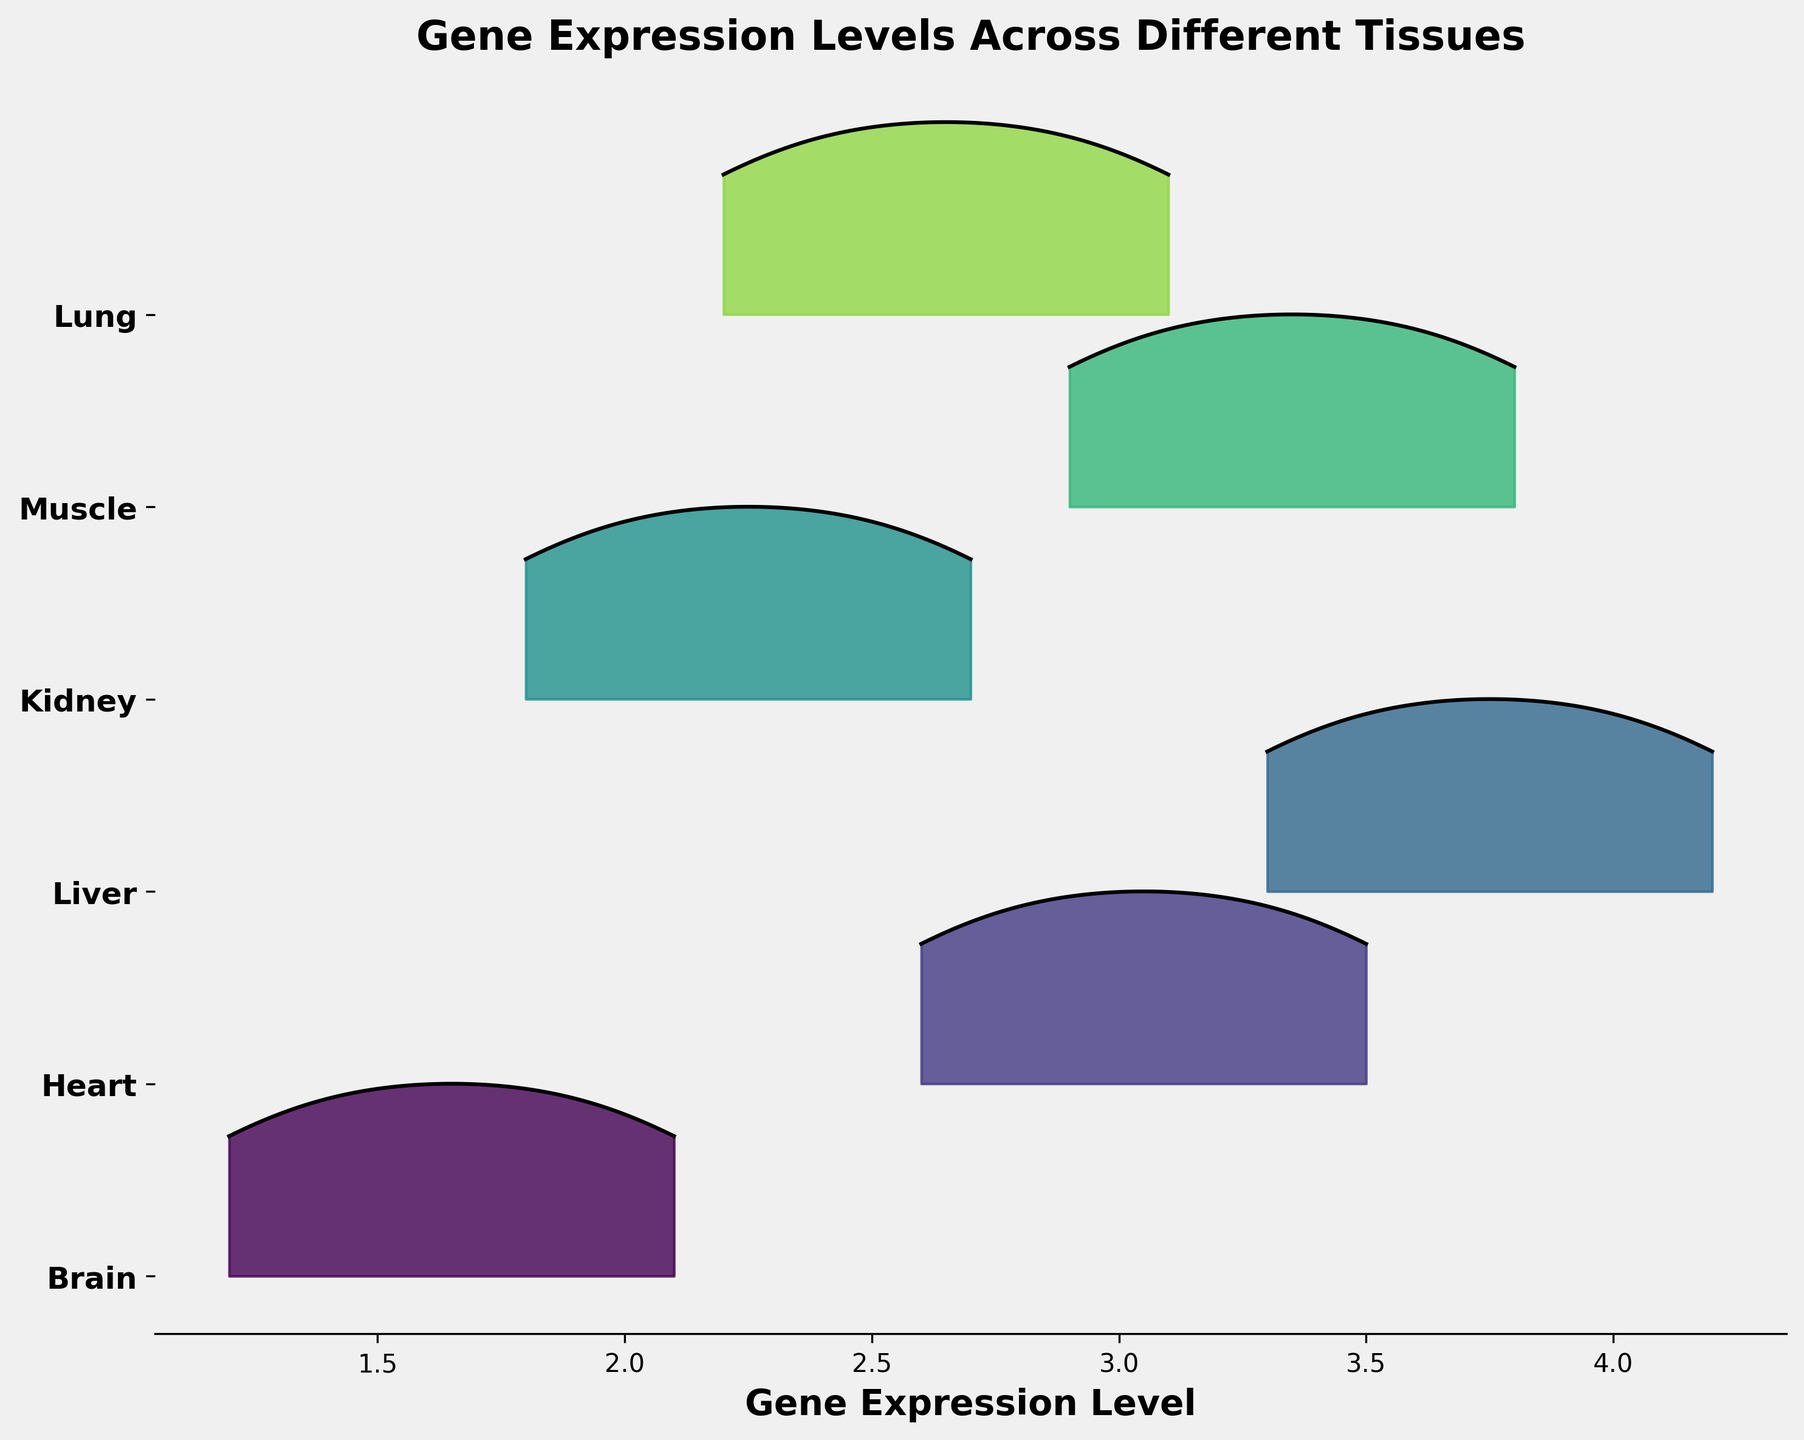What tissues are examined in the Ridgeline plot? The y-axis labels represent different tissues examined in the plot, they are Brain, Heart, Liver, Kidney, Muscle, and Lung.
Answer: Brain, Heart, Liver, Kidney, Muscle, Lung Which tissue shows the highest gene expression level? By examining the peaks in the ridgelines, the Liver tissue extends to the highest gene expression level, around 4.2.
Answer: Liver How is the gene expression level distributed for the Brain tissue? The Brain tissue has multiple peaks with a maximum near 2.1, which can be observed through its ridgeline pattern.
Answer: Multi-peaked, max around 2.1 What is the general range of gene expression levels across all tissues? By observing the x-axis range covered by all ridgelines, the general range is between 1.2 and 4.2.
Answer: 1.2 to 4.2 How do Muscle and Lung tissues compare in their gene expression levels? The peak gene expression levels for Muscle and Lung tissues are compared; Muscle peaks around 3.8 while Lung peaks around 3.1.
Answer: Muscle > Lung Which tissue appears to have the most uniform distribution of gene expression levels? By visual inspection, Kidney tissue shows the most uniform ridgeline without sharp peaks, indicating a more even distribution.
Answer: Kidney Is there any tissue where the gene expression does not exceed 3.0? By checking the ridgelines, Brain and Kidney have maximum gene expression levels beneath 3.0.
Answer: Brain, Kidney Do any tissues have overlapping gene expression levels? Yes, several ridgelines overlap, notably the peak levels of Brain and Kidney both cover around 1.8-2.7.
Answer: Yes What is the average maximum gene expression level across Heart, Liver, and Muscle tissues? Add the highest expression levels of Heart (3.5), Liver (4.2), and Muscle (3.8), then divide by three: (3.5 + 4.2 + 3.8) / 3 = 3.83.
Answer: 3.83 How many genes are evaluated per tissue in the plot? Counting peaks per tissue: each tissue consistently shows four peaks, indicating four genes measured per tissue.
Answer: Four 